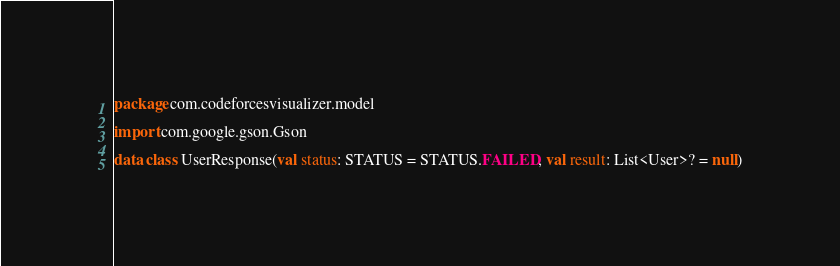Convert code to text. <code><loc_0><loc_0><loc_500><loc_500><_Kotlin_>package com.codeforcesvisualizer.model

import com.google.gson.Gson

data class UserResponse(val status: STATUS = STATUS.FAILED, val result: List<User>? = null)</code> 